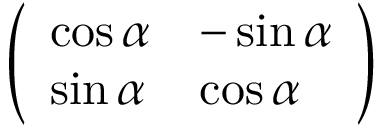Convert formula to latex. <formula><loc_0><loc_0><loc_500><loc_500>\left ( \begin{array} { l l } { \cos \alpha } & { - \sin \alpha } \\ { \sin \alpha } & { \cos \alpha } \end{array} \right )</formula> 